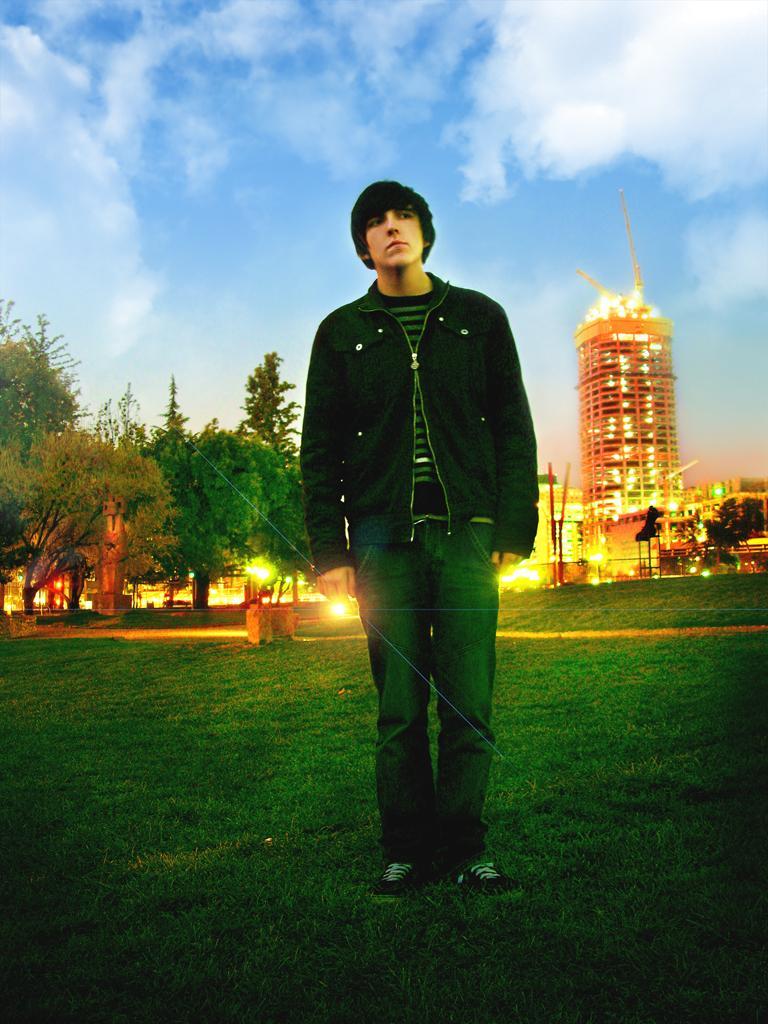How would you summarize this image in a sentence or two? In this picture there is boy wearing black color jacket standing on the green lawn and giving a pose into the camera. Behind we can see some trees and and building. 